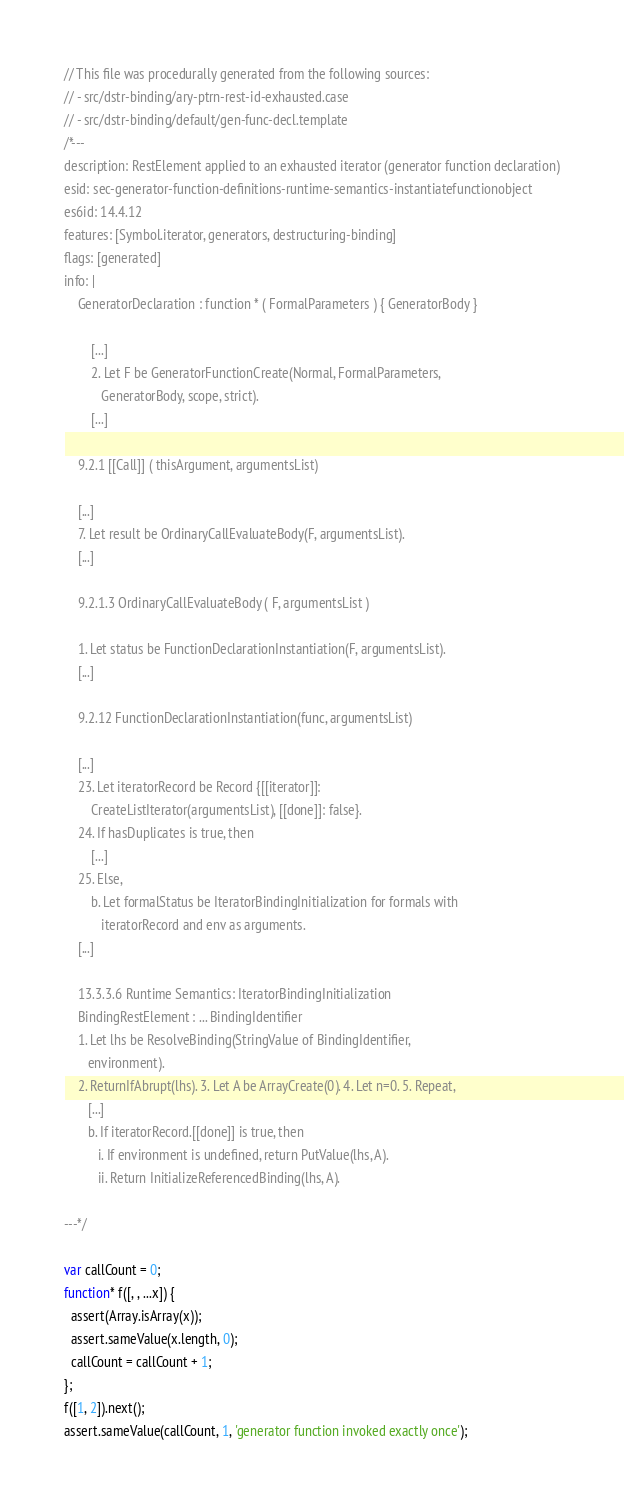Convert code to text. <code><loc_0><loc_0><loc_500><loc_500><_JavaScript_>// This file was procedurally generated from the following sources:
// - src/dstr-binding/ary-ptrn-rest-id-exhausted.case
// - src/dstr-binding/default/gen-func-decl.template
/*---
description: RestElement applied to an exhausted iterator (generator function declaration)
esid: sec-generator-function-definitions-runtime-semantics-instantiatefunctionobject
es6id: 14.4.12
features: [Symbol.iterator, generators, destructuring-binding]
flags: [generated]
info: |
    GeneratorDeclaration : function * ( FormalParameters ) { GeneratorBody }

        [...]
        2. Let F be GeneratorFunctionCreate(Normal, FormalParameters,
           GeneratorBody, scope, strict).
        [...]

    9.2.1 [[Call]] ( thisArgument, argumentsList)

    [...]
    7. Let result be OrdinaryCallEvaluateBody(F, argumentsList).
    [...]

    9.2.1.3 OrdinaryCallEvaluateBody ( F, argumentsList )

    1. Let status be FunctionDeclarationInstantiation(F, argumentsList).
    [...]

    9.2.12 FunctionDeclarationInstantiation(func, argumentsList)

    [...]
    23. Let iteratorRecord be Record {[[iterator]]:
        CreateListIterator(argumentsList), [[done]]: false}.
    24. If hasDuplicates is true, then
        [...]
    25. Else,
        b. Let formalStatus be IteratorBindingInitialization for formals with
           iteratorRecord and env as arguments.
    [...]

    13.3.3.6 Runtime Semantics: IteratorBindingInitialization
    BindingRestElement : ... BindingIdentifier
    1. Let lhs be ResolveBinding(StringValue of BindingIdentifier,
       environment).
    2. ReturnIfAbrupt(lhs). 3. Let A be ArrayCreate(0). 4. Let n=0. 5. Repeat,
       [...]
       b. If iteratorRecord.[[done]] is true, then
          i. If environment is undefined, return PutValue(lhs, A).
          ii. Return InitializeReferencedBinding(lhs, A).

---*/

var callCount = 0;
function* f([, , ...x]) {
  assert(Array.isArray(x));
  assert.sameValue(x.length, 0);
  callCount = callCount + 1;
};
f([1, 2]).next();
assert.sameValue(callCount, 1, 'generator function invoked exactly once');
</code> 